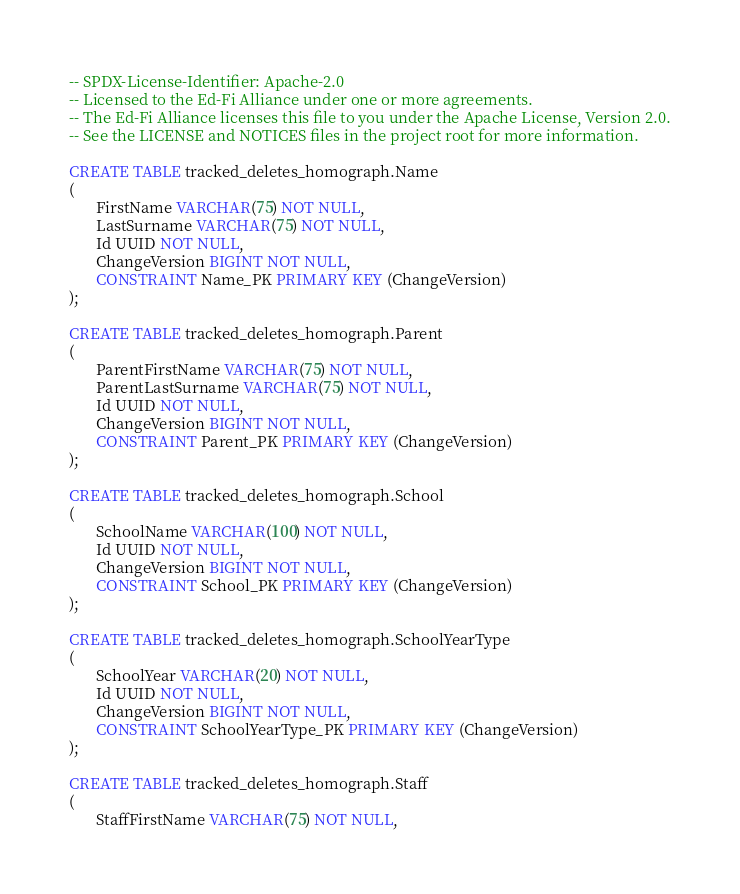Convert code to text. <code><loc_0><loc_0><loc_500><loc_500><_SQL_>-- SPDX-License-Identifier: Apache-2.0
-- Licensed to the Ed-Fi Alliance under one or more agreements.
-- The Ed-Fi Alliance licenses this file to you under the Apache License, Version 2.0.
-- See the LICENSE and NOTICES files in the project root for more information.

CREATE TABLE tracked_deletes_homograph.Name
(
       FirstName VARCHAR(75) NOT NULL,
       LastSurname VARCHAR(75) NOT NULL,
       Id UUID NOT NULL,
       ChangeVersion BIGINT NOT NULL,
       CONSTRAINT Name_PK PRIMARY KEY (ChangeVersion)
);

CREATE TABLE tracked_deletes_homograph.Parent
(
       ParentFirstName VARCHAR(75) NOT NULL,
       ParentLastSurname VARCHAR(75) NOT NULL,
       Id UUID NOT NULL,
       ChangeVersion BIGINT NOT NULL,
       CONSTRAINT Parent_PK PRIMARY KEY (ChangeVersion)
);

CREATE TABLE tracked_deletes_homograph.School
(
       SchoolName VARCHAR(100) NOT NULL,
       Id UUID NOT NULL,
       ChangeVersion BIGINT NOT NULL,
       CONSTRAINT School_PK PRIMARY KEY (ChangeVersion)
);

CREATE TABLE tracked_deletes_homograph.SchoolYearType
(
       SchoolYear VARCHAR(20) NOT NULL,
       Id UUID NOT NULL,
       ChangeVersion BIGINT NOT NULL,
       CONSTRAINT SchoolYearType_PK PRIMARY KEY (ChangeVersion)
);

CREATE TABLE tracked_deletes_homograph.Staff
(
       StaffFirstName VARCHAR(75) NOT NULL,</code> 